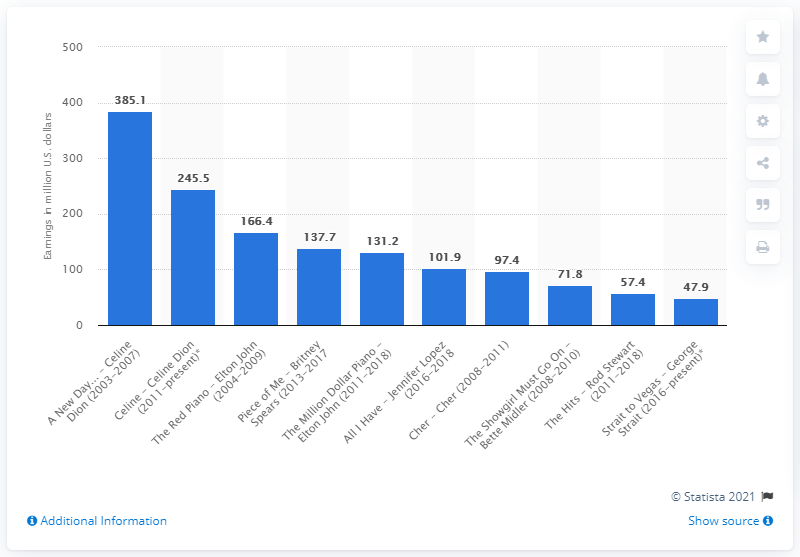Draw attention to some important aspects in this diagram. According to the latest data available as of late 2018, Celine Dion's residency had earned a total of 245.5 million US dollars. 